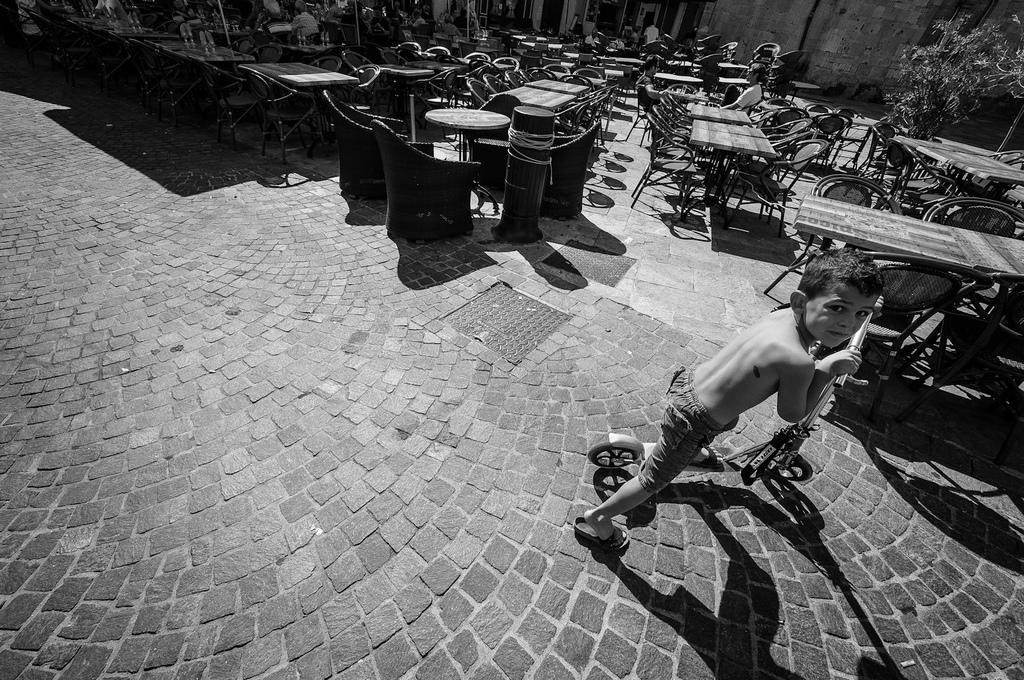What is the main subject of the image? The main subject of the image is a kid. What is the kid doing in the image? The kid is playing with a cycle. Are there any other people in the image? Yes, there are people sitting on chairs in the image. What is the color scheme of the image? The image is in black and white color. What type of soda is the kid drinking in the image? There is no soda present in the image; the kid is playing with a cycle. What religious symbols can be seen in the image? There are no religious symbols present in the image; it features a kid playing with a cycle and people sitting on chairs in a black and white setting. 